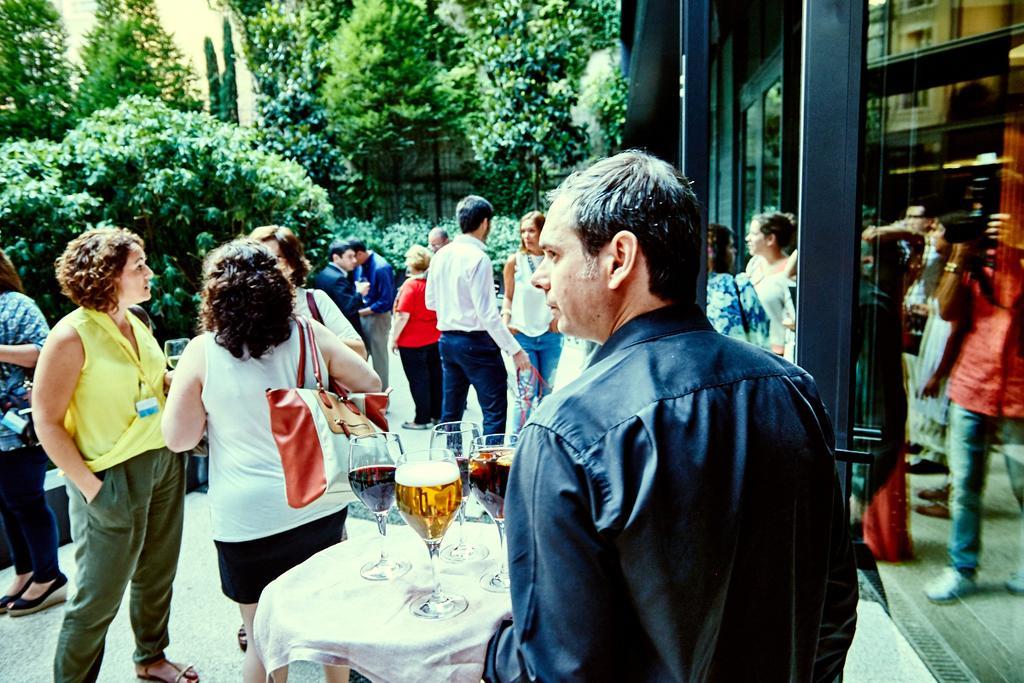In one or two sentences, can you explain what this image depicts? In the foreground of the picture there are people. In the middle we can see a person holding a tray, on the train there are glasses. In the background there are trees. On the right we can see a glass window and a building. 